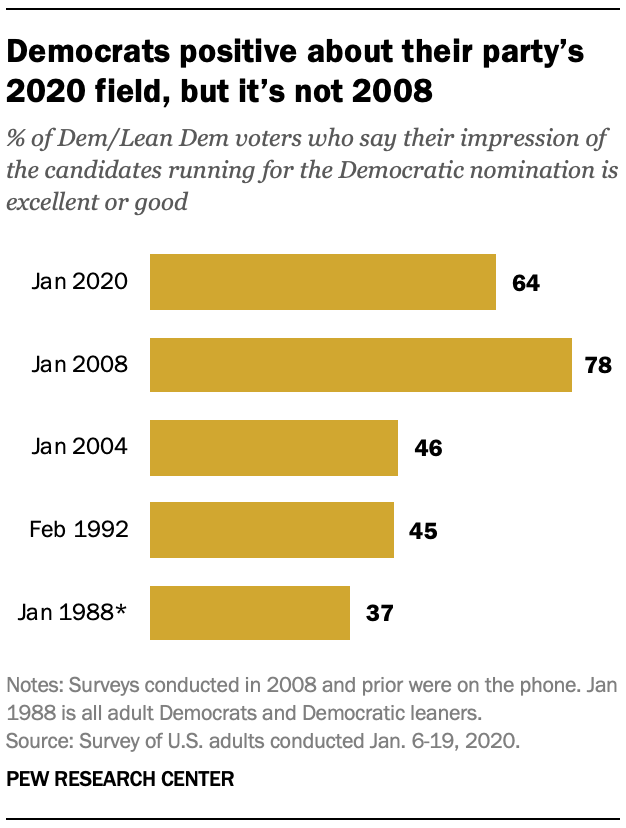Outline some significant characteristics in this image. The sum of the median of all the bars and the average of the two smallest bars is 87. The value of the bar in January 2008 was 78. 